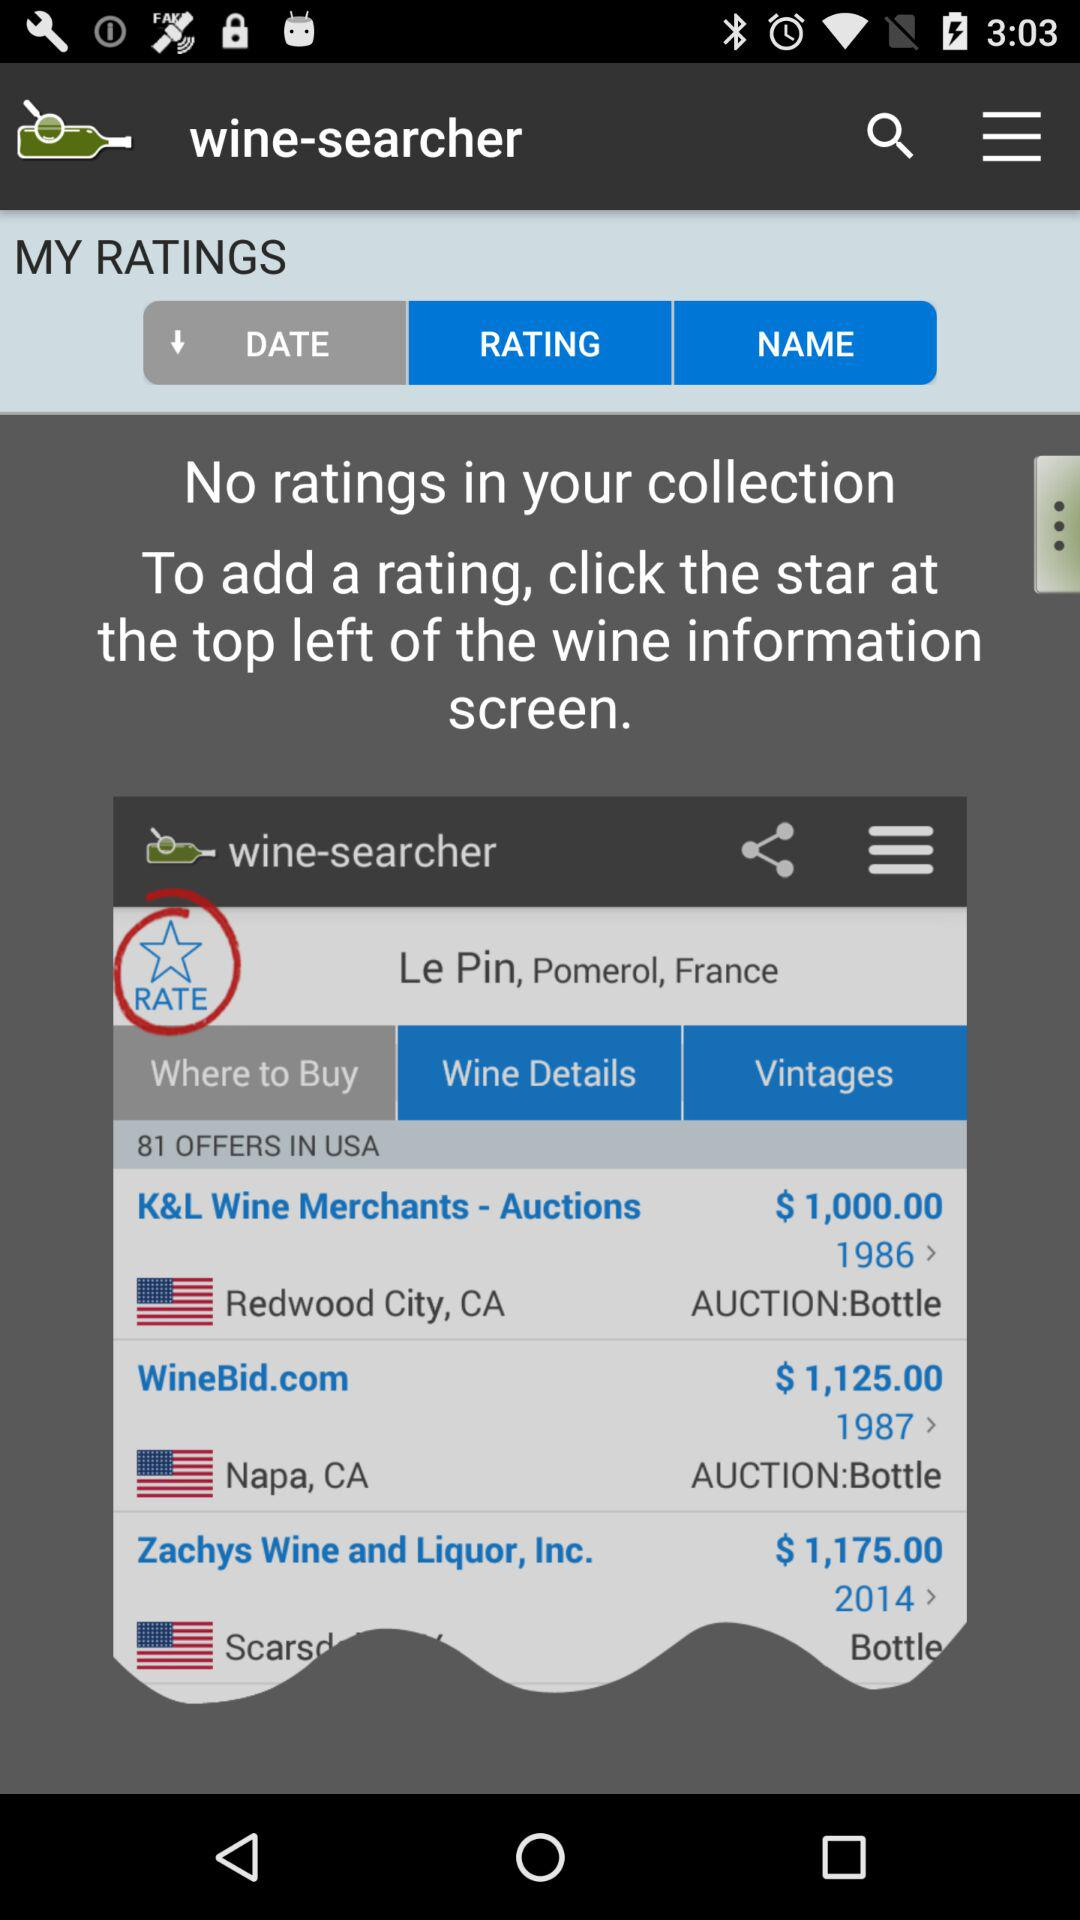Where to click to add a rating? To add a rating click the star at the top left of the wine information screen. 